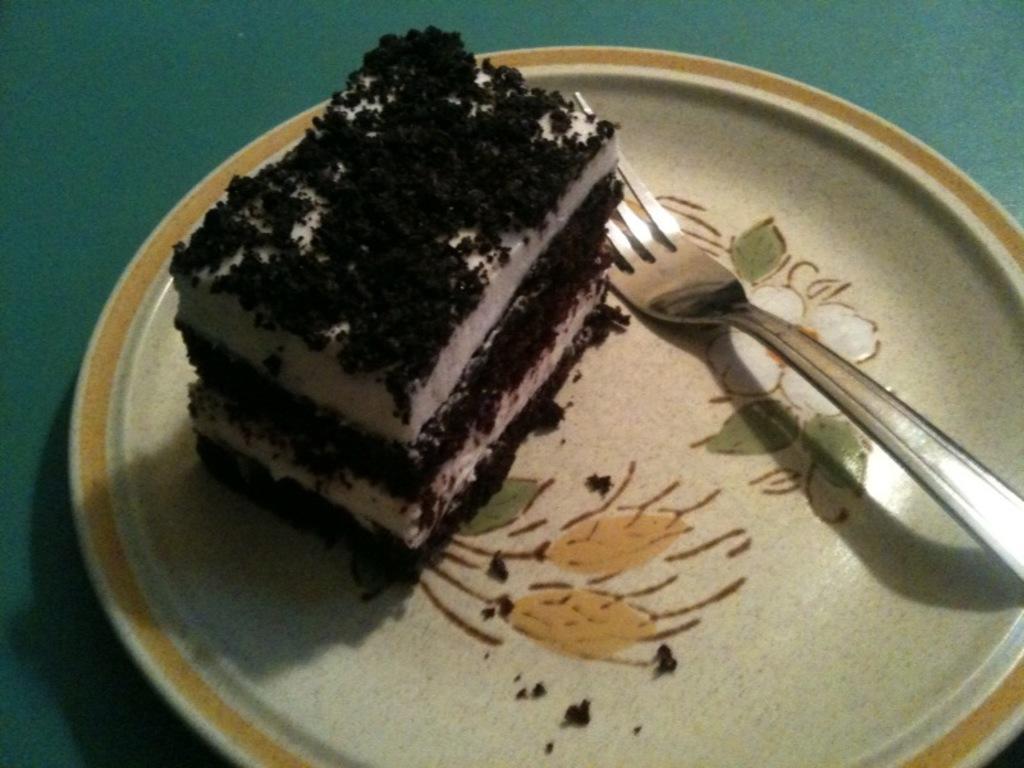Describe this image in one or two sentences. On this planet there is a piece of cake and fork. This plate is kept on a green surface. 